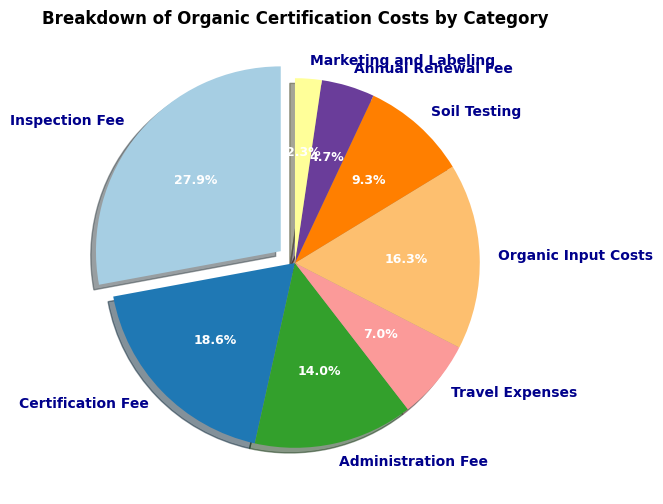What percentage of the total cost does the Inspection Fee constitute? To determine the percentage, divide the Inspection Fee by the total cost and multiply by 100. Here, the Inspection Fee is $1,200. The total cost is $1,200 + $800 + $600 + $300 + $700 + $400 + $200 + $100 = $4,300. Thus, (1200 / 4300) * 100 ≈ 27.9%
Answer: 27.9% Which category has the highest cost? The largest slice in the pie chart is the one that represents the Inspection Fee.
Answer: Inspection Fee How much more does the Certification Fee cost compared to the Administration Fee? The Certification Fee is $800, and the Administration Fee is $600. The difference is $800 - $600 = $200.
Answer: $200 What is the combined cost of Organic Input Costs and Soil Testing? Sum the costs: $700 (Organic Input Costs) + $400 (Soil Testing) = $1,100.
Answer: $1,100 Is the cost of Travel Expenses greater than the cost of Annual Renewal Fee? The slice representing Travel Expenses is larger than the slice for Annual Renewal Fee. Travel Expenses cost $300 and Annual Renewal Fee costs $200, so $300 > $200.
Answer: Yes Which categories combined make up exactly half of the total cost? The total cost is $4,300. Half of this is $2,150. Adding up the largest individual costs until the sum is $2,150: $1,200 (Inspection Fee) + $800 (Certification Fee) + $150 (part of Administration Fee) = $2,150. Therefore, Inspection Fee and Certification Fee combined make up half the total cost.
Answer: Inspection Fee and Certification Fee plus half of Administration Fee What percentage of the total cost is spent on Marketing and Labeling? To find the percentage, divide the cost of Marketing and Labeling by the total cost and multiply by 100. Here, Marketing and Labeling cost $100. Total cost is $4,300. Thus, (100 / 4300) * 100 ≈ 2.3%
Answer: 2.3% What is the average cost per category? To find the average, divide the total cost by the number of categories. Total cost is $4,300. There are 8 categories. So, $4,300 / 8 = $537.5
Answer: $537.50 How does the cost of Soil Testing compare to that of Organic Input Costs? Soil Testing costs $400, while Organic Input Costs are $700. $400 is less than $700.
Answer: Soil Testing is less than Organic Input Costs Which category has the smallest cost, and what is that cost? The smallest slice in the pie chart represents Marketing and Labeling, which costs $100.
Answer: Marketing and Labeling, $100 